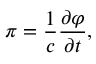<formula> <loc_0><loc_0><loc_500><loc_500>\pi = \frac { 1 } { c } \frac { \partial \varphi } { \partial t } ,</formula> 